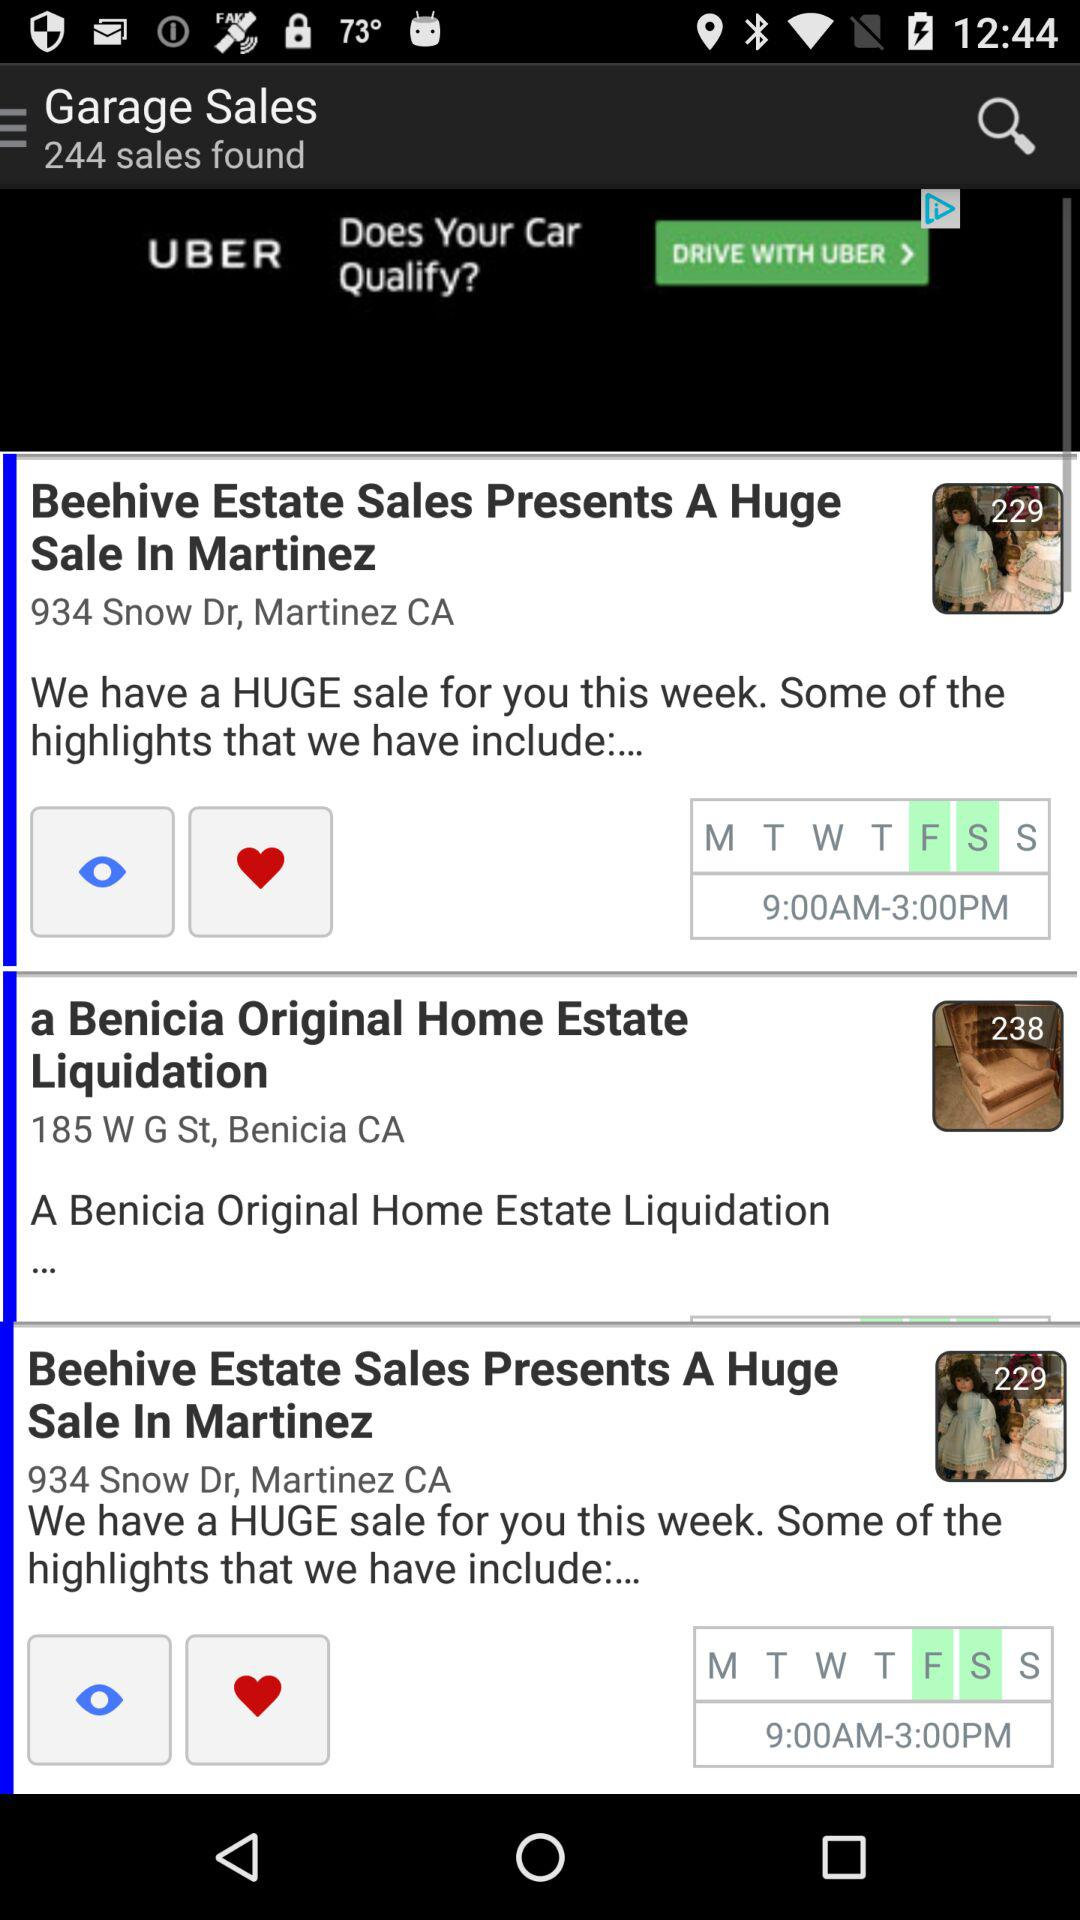What time range is shown? The shown time range is 9:00 a.m.–3:00 p.m. 